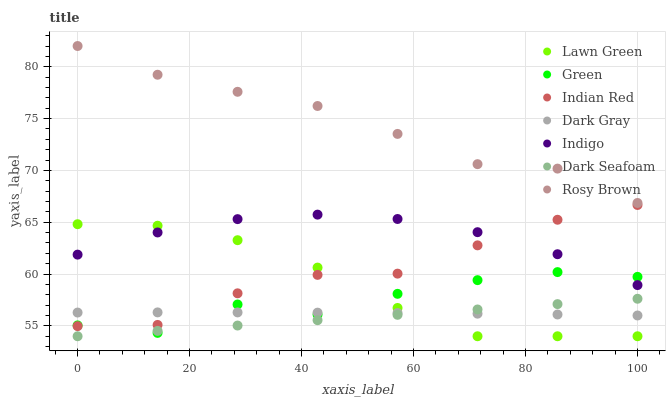Does Dark Seafoam have the minimum area under the curve?
Answer yes or no. Yes. Does Rosy Brown have the maximum area under the curve?
Answer yes or no. Yes. Does Indigo have the minimum area under the curve?
Answer yes or no. No. Does Indigo have the maximum area under the curve?
Answer yes or no. No. Is Dark Seafoam the smoothest?
Answer yes or no. Yes. Is Green the roughest?
Answer yes or no. Yes. Is Indigo the smoothest?
Answer yes or no. No. Is Indigo the roughest?
Answer yes or no. No. Does Lawn Green have the lowest value?
Answer yes or no. Yes. Does Indigo have the lowest value?
Answer yes or no. No. Does Rosy Brown have the highest value?
Answer yes or no. Yes. Does Indigo have the highest value?
Answer yes or no. No. Is Indigo less than Rosy Brown?
Answer yes or no. Yes. Is Rosy Brown greater than Dark Gray?
Answer yes or no. Yes. Does Dark Gray intersect Green?
Answer yes or no. Yes. Is Dark Gray less than Green?
Answer yes or no. No. Is Dark Gray greater than Green?
Answer yes or no. No. Does Indigo intersect Rosy Brown?
Answer yes or no. No. 